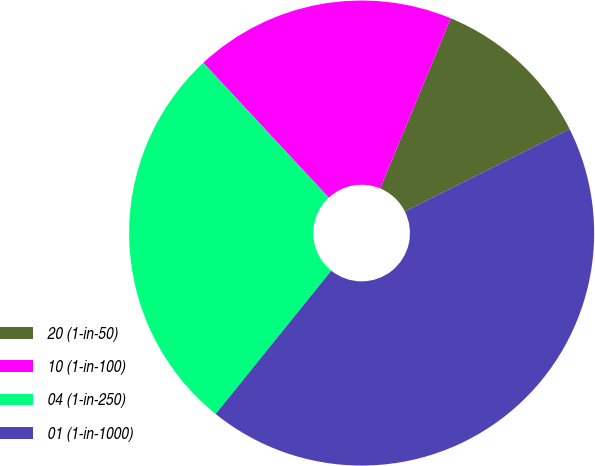<chart> <loc_0><loc_0><loc_500><loc_500><pie_chart><fcel>20 (1-in-50)<fcel>10 (1-in-100)<fcel>04 (1-in-250)<fcel>01 (1-in-1000)<nl><fcel>11.36%<fcel>18.18%<fcel>27.27%<fcel>43.18%<nl></chart> 